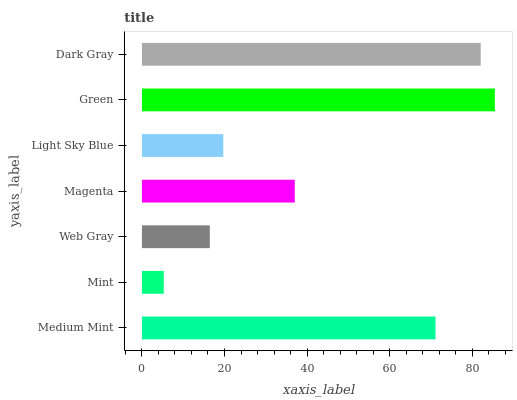Is Mint the minimum?
Answer yes or no. Yes. Is Green the maximum?
Answer yes or no. Yes. Is Web Gray the minimum?
Answer yes or no. No. Is Web Gray the maximum?
Answer yes or no. No. Is Web Gray greater than Mint?
Answer yes or no. Yes. Is Mint less than Web Gray?
Answer yes or no. Yes. Is Mint greater than Web Gray?
Answer yes or no. No. Is Web Gray less than Mint?
Answer yes or no. No. Is Magenta the high median?
Answer yes or no. Yes. Is Magenta the low median?
Answer yes or no. Yes. Is Web Gray the high median?
Answer yes or no. No. Is Dark Gray the low median?
Answer yes or no. No. 